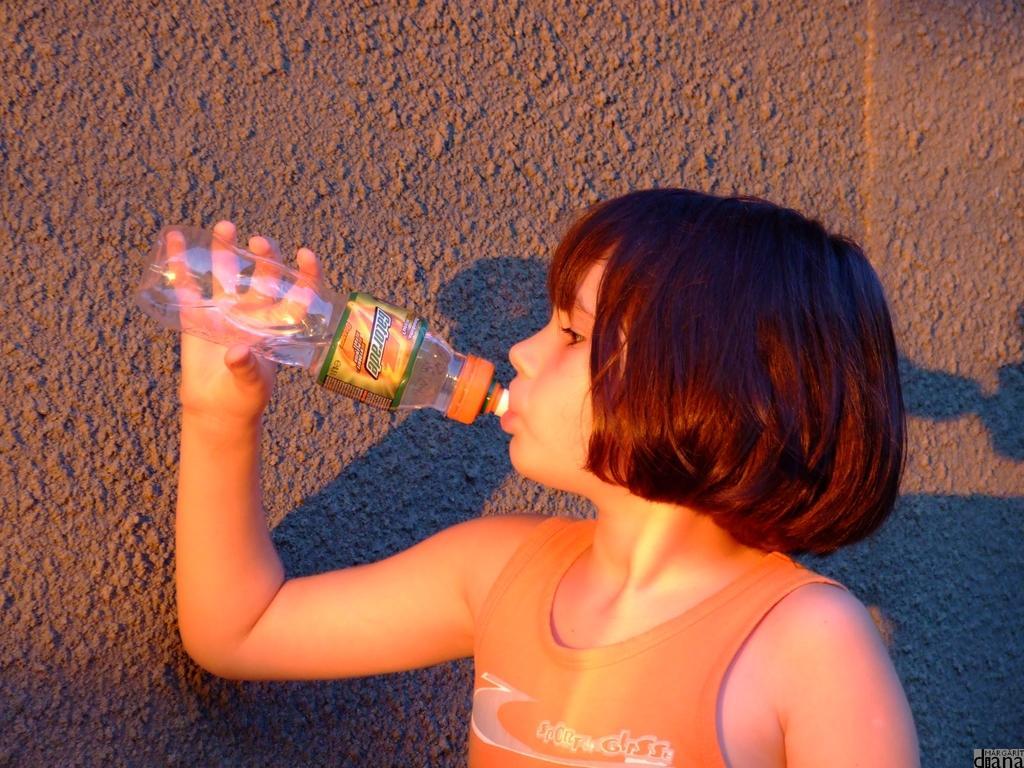Could you give a brief overview of what you see in this image? In this picture I can see a child who is holding a bottle near to the mouth and I can see a sticker on the bottle. In the background I can see the wall and I can see a shadow. On the right bottom corner of this picture I can see the watermark. 